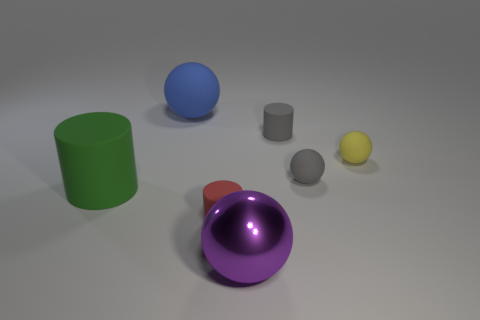What shape is the gray object right of the cylinder on the right side of the big purple sphere?
Your answer should be compact. Sphere. Is the number of big spheres that are on the right side of the red rubber thing less than the number of blue spheres that are right of the gray rubber cylinder?
Your answer should be very brief. No. What size is the purple object that is the same shape as the blue object?
Provide a short and direct response. Large. How many things are either big balls behind the red matte thing or big shiny things that are right of the red rubber object?
Your answer should be compact. 2. Do the blue ball and the metallic ball have the same size?
Provide a succinct answer. Yes. Are there more small red things than tiny things?
Keep it short and to the point. No. What number of other things are the same color as the metal sphere?
Ensure brevity in your answer.  0. How many things are either big blue matte spheres or tiny rubber cubes?
Offer a very short reply. 1. There is a big matte object in front of the small gray matte sphere; is it the same shape as the blue rubber thing?
Your answer should be compact. No. There is a small rubber cylinder that is right of the big thing in front of the big matte cylinder; what color is it?
Ensure brevity in your answer.  Gray. 